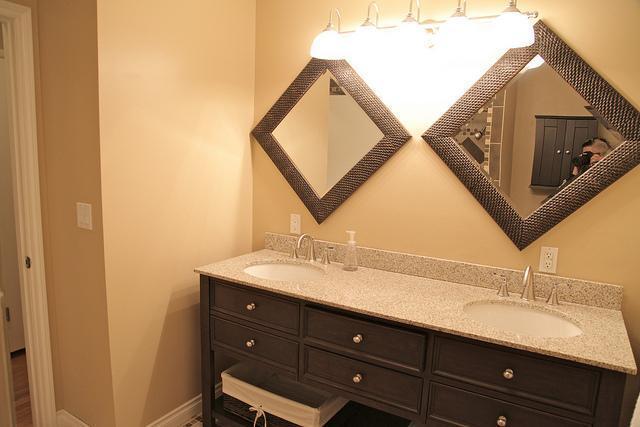How many mirrors are there?
Give a very brief answer. 2. How many forks are there?
Give a very brief answer. 0. 